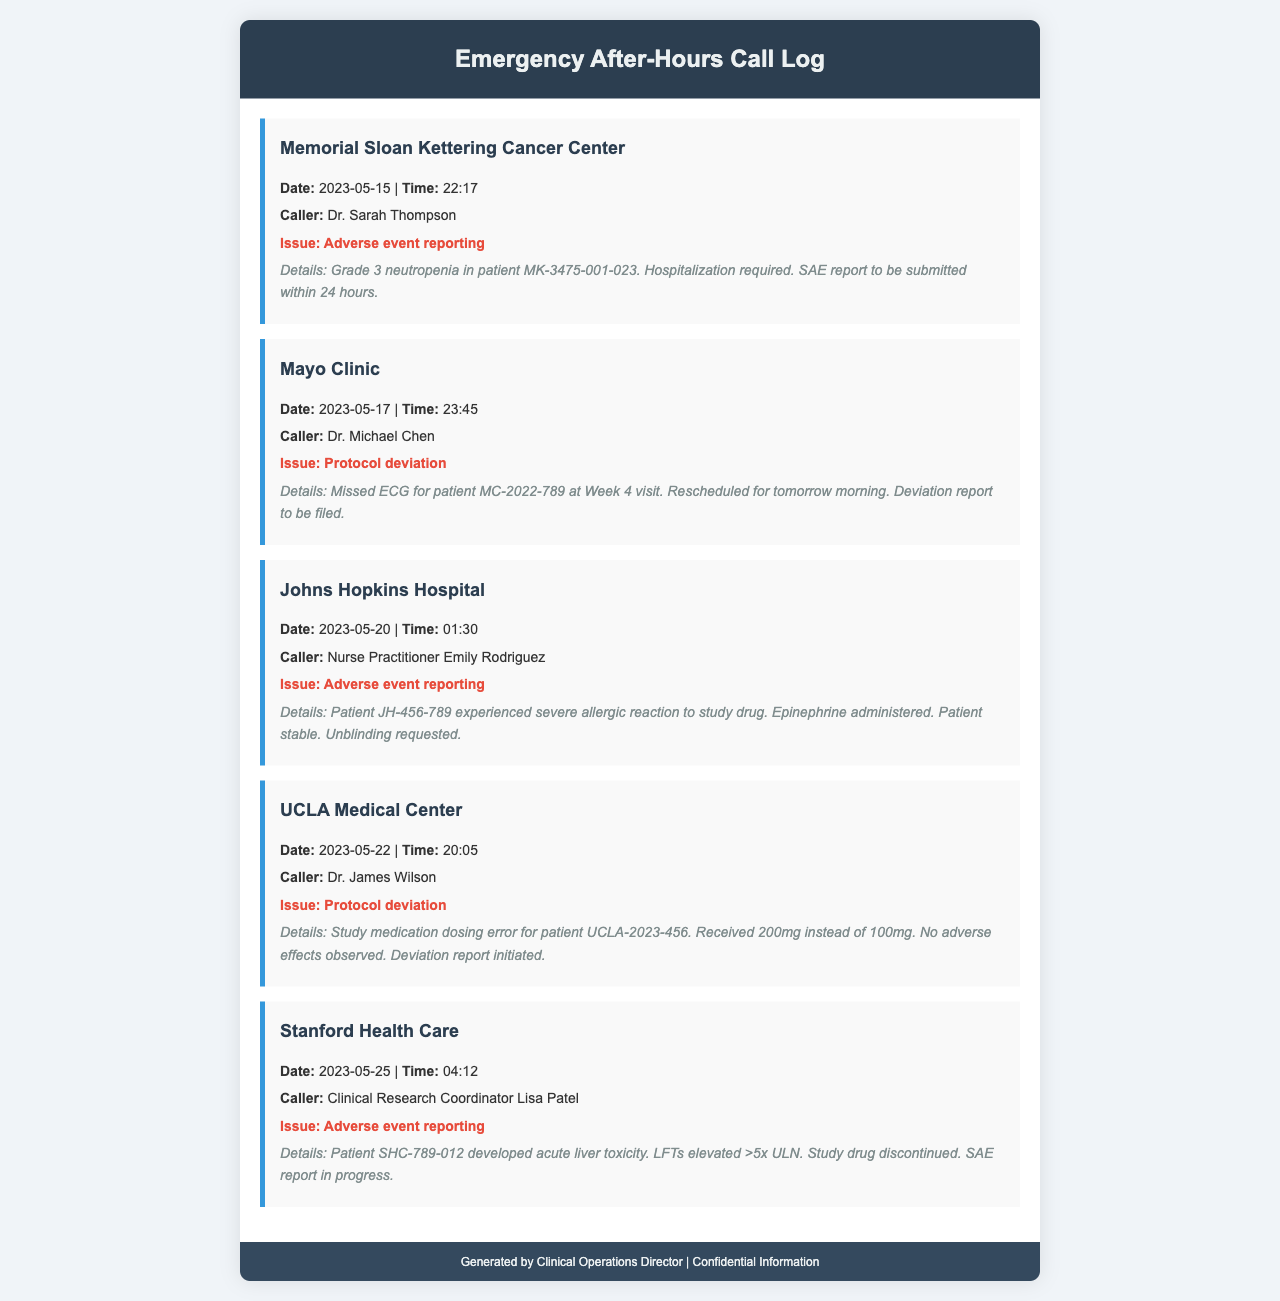What is the date of the first call? The first call is logged on May 15, 2023.
Answer: May 15, 2023 Who reported the adverse event at Johns Hopkins Hospital? The adverse event at Johns Hopkins Hospital was reported by Nurse Practitioner Emily Rodriguez.
Answer: Emily Rodriguez What issue was reported by Dr. Michael Chen at Mayo Clinic? Dr. Michael Chen reported a protocol deviation.
Answer: Protocol deviation What is the time of the call from UCLA Medical Center? The call from UCLA Medical Center took place at 20:05.
Answer: 20:05 How many adverse events are noted in the log? There are three adverse events noted in the log.
Answer: Three What was the patient identifier for the hospitalization case at Memorial Sloan Kettering Cancer Center? The patient identifier for the hospitalization case is MK-3475-001-023.
Answer: MK-3475-001-023 Which research site reported a study medication dosing error? The research site that reported a dosing error is UCLA Medical Center.
Answer: UCLA Medical Center What action is being taken in response to the adverse event at Stanford Health Care? An SAE report is in progress in response to the adverse event.
Answer: SAE report in progress What was the issue reported by Dr. James Wilson on May 22? The issue reported by Dr. James Wilson was a protocol deviation.
Answer: Protocol deviation 